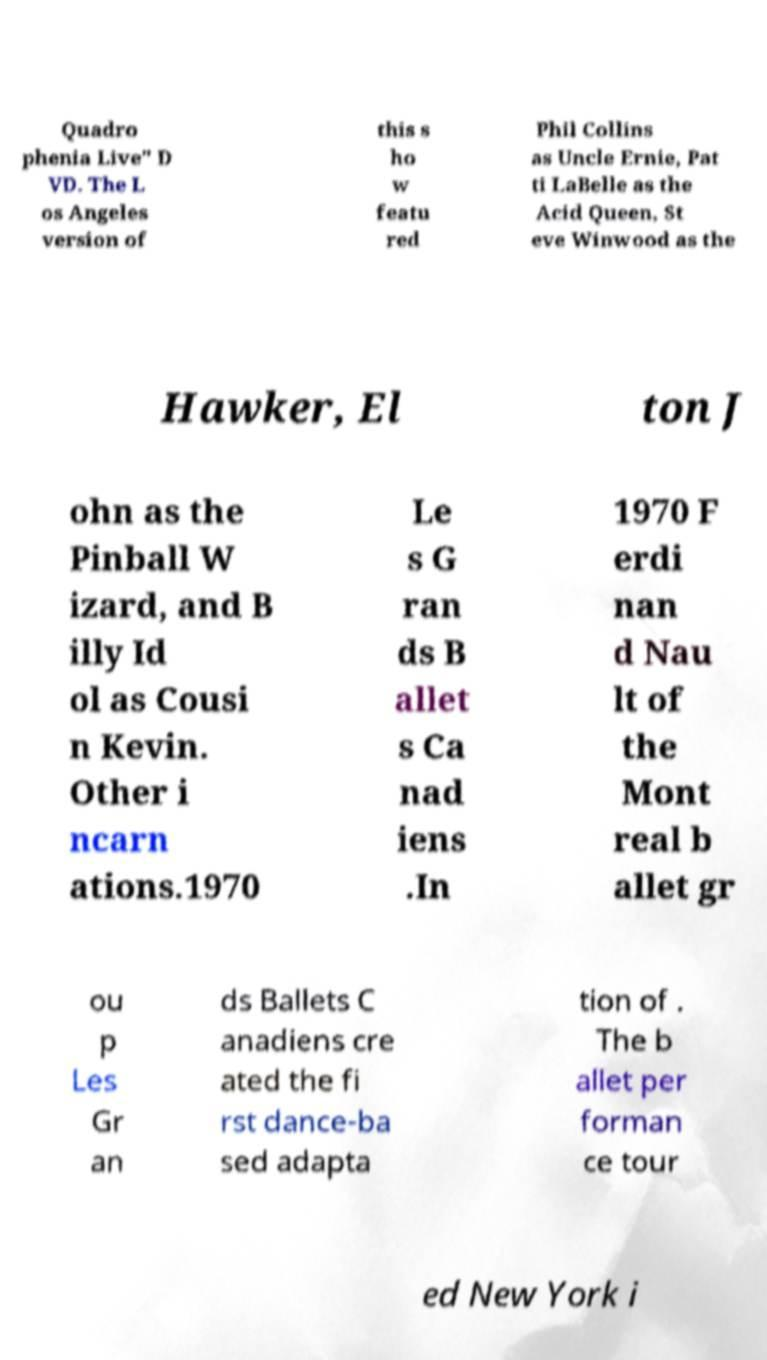Can you read and provide the text displayed in the image?This photo seems to have some interesting text. Can you extract and type it out for me? Quadro phenia Live" D VD. The L os Angeles version of this s ho w featu red Phil Collins as Uncle Ernie, Pat ti LaBelle as the Acid Queen, St eve Winwood as the Hawker, El ton J ohn as the Pinball W izard, and B illy Id ol as Cousi n Kevin. Other i ncarn ations.1970 Le s G ran ds B allet s Ca nad iens .In 1970 F erdi nan d Nau lt of the Mont real b allet gr ou p Les Gr an ds Ballets C anadiens cre ated the fi rst dance-ba sed adapta tion of . The b allet per forman ce tour ed New York i 